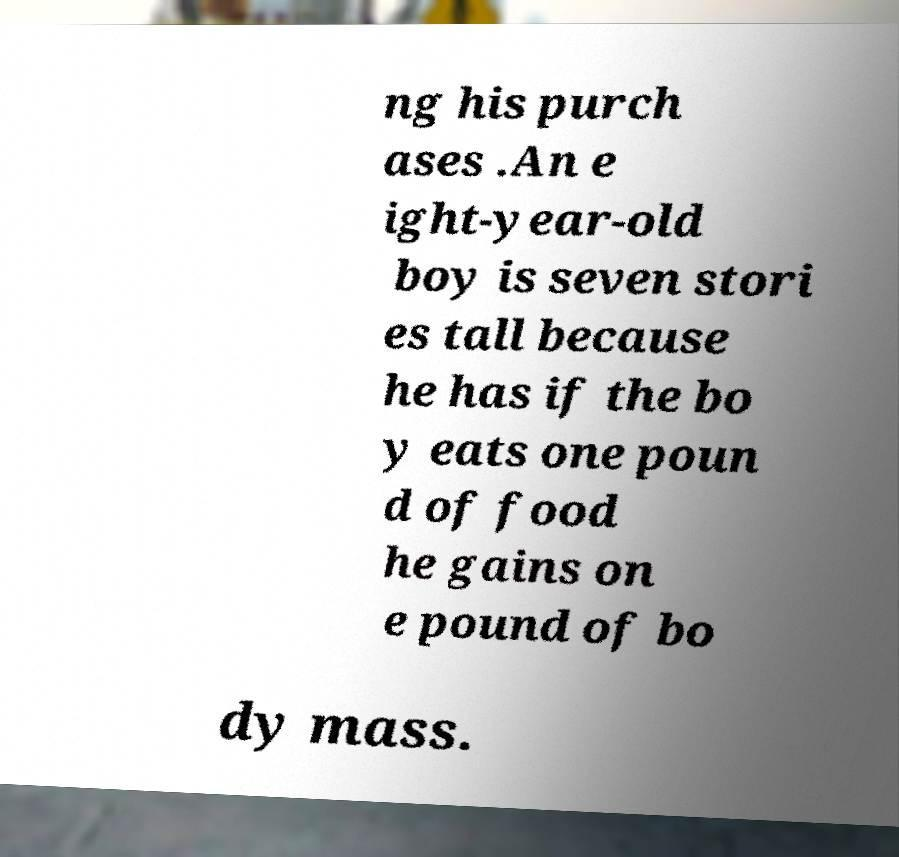I need the written content from this picture converted into text. Can you do that? ng his purch ases .An e ight-year-old boy is seven stori es tall because he has if the bo y eats one poun d of food he gains on e pound of bo dy mass. 